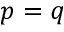Convert formula to latex. <formula><loc_0><loc_0><loc_500><loc_500>p = q</formula> 